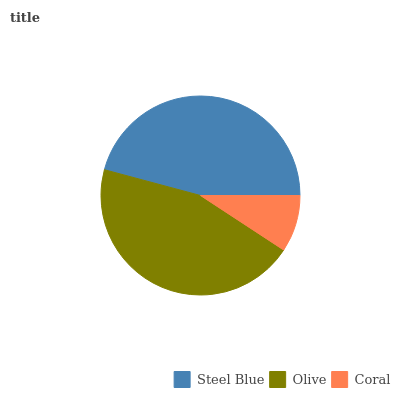Is Coral the minimum?
Answer yes or no. Yes. Is Steel Blue the maximum?
Answer yes or no. Yes. Is Olive the minimum?
Answer yes or no. No. Is Olive the maximum?
Answer yes or no. No. Is Steel Blue greater than Olive?
Answer yes or no. Yes. Is Olive less than Steel Blue?
Answer yes or no. Yes. Is Olive greater than Steel Blue?
Answer yes or no. No. Is Steel Blue less than Olive?
Answer yes or no. No. Is Olive the high median?
Answer yes or no. Yes. Is Olive the low median?
Answer yes or no. Yes. Is Steel Blue the high median?
Answer yes or no. No. Is Steel Blue the low median?
Answer yes or no. No. 